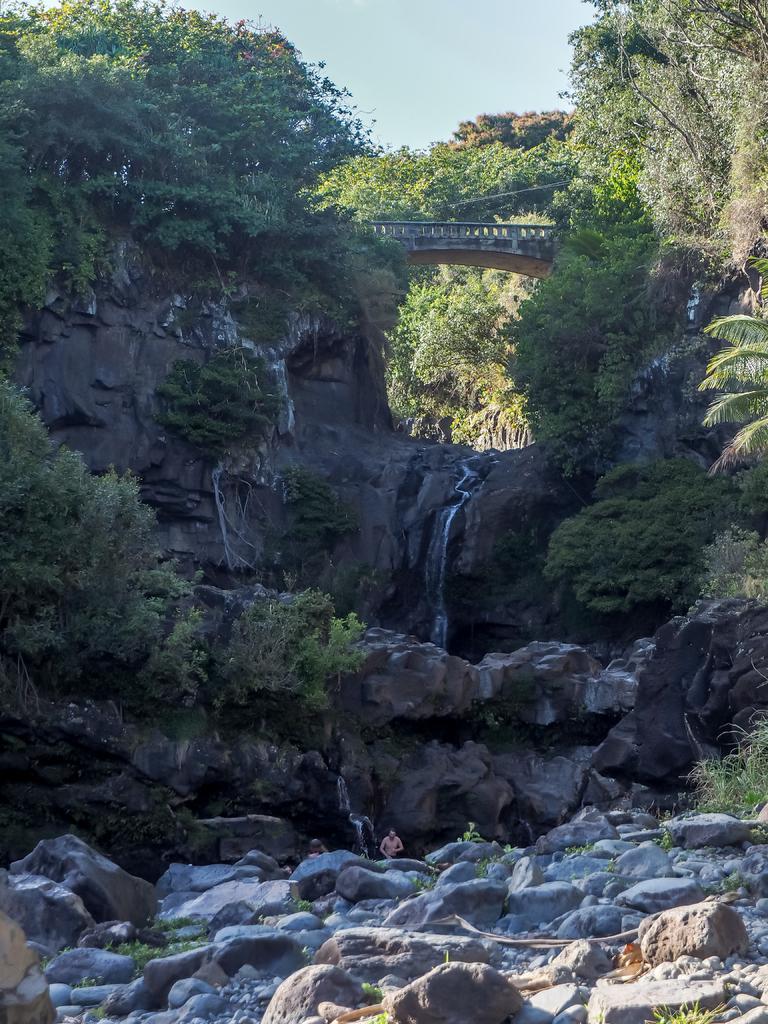Could you give a brief overview of what you see in this image? In the picture we can see a forest area with rocks and rock hill with some plants to it and top of the hill we can see some rocks and sky. 